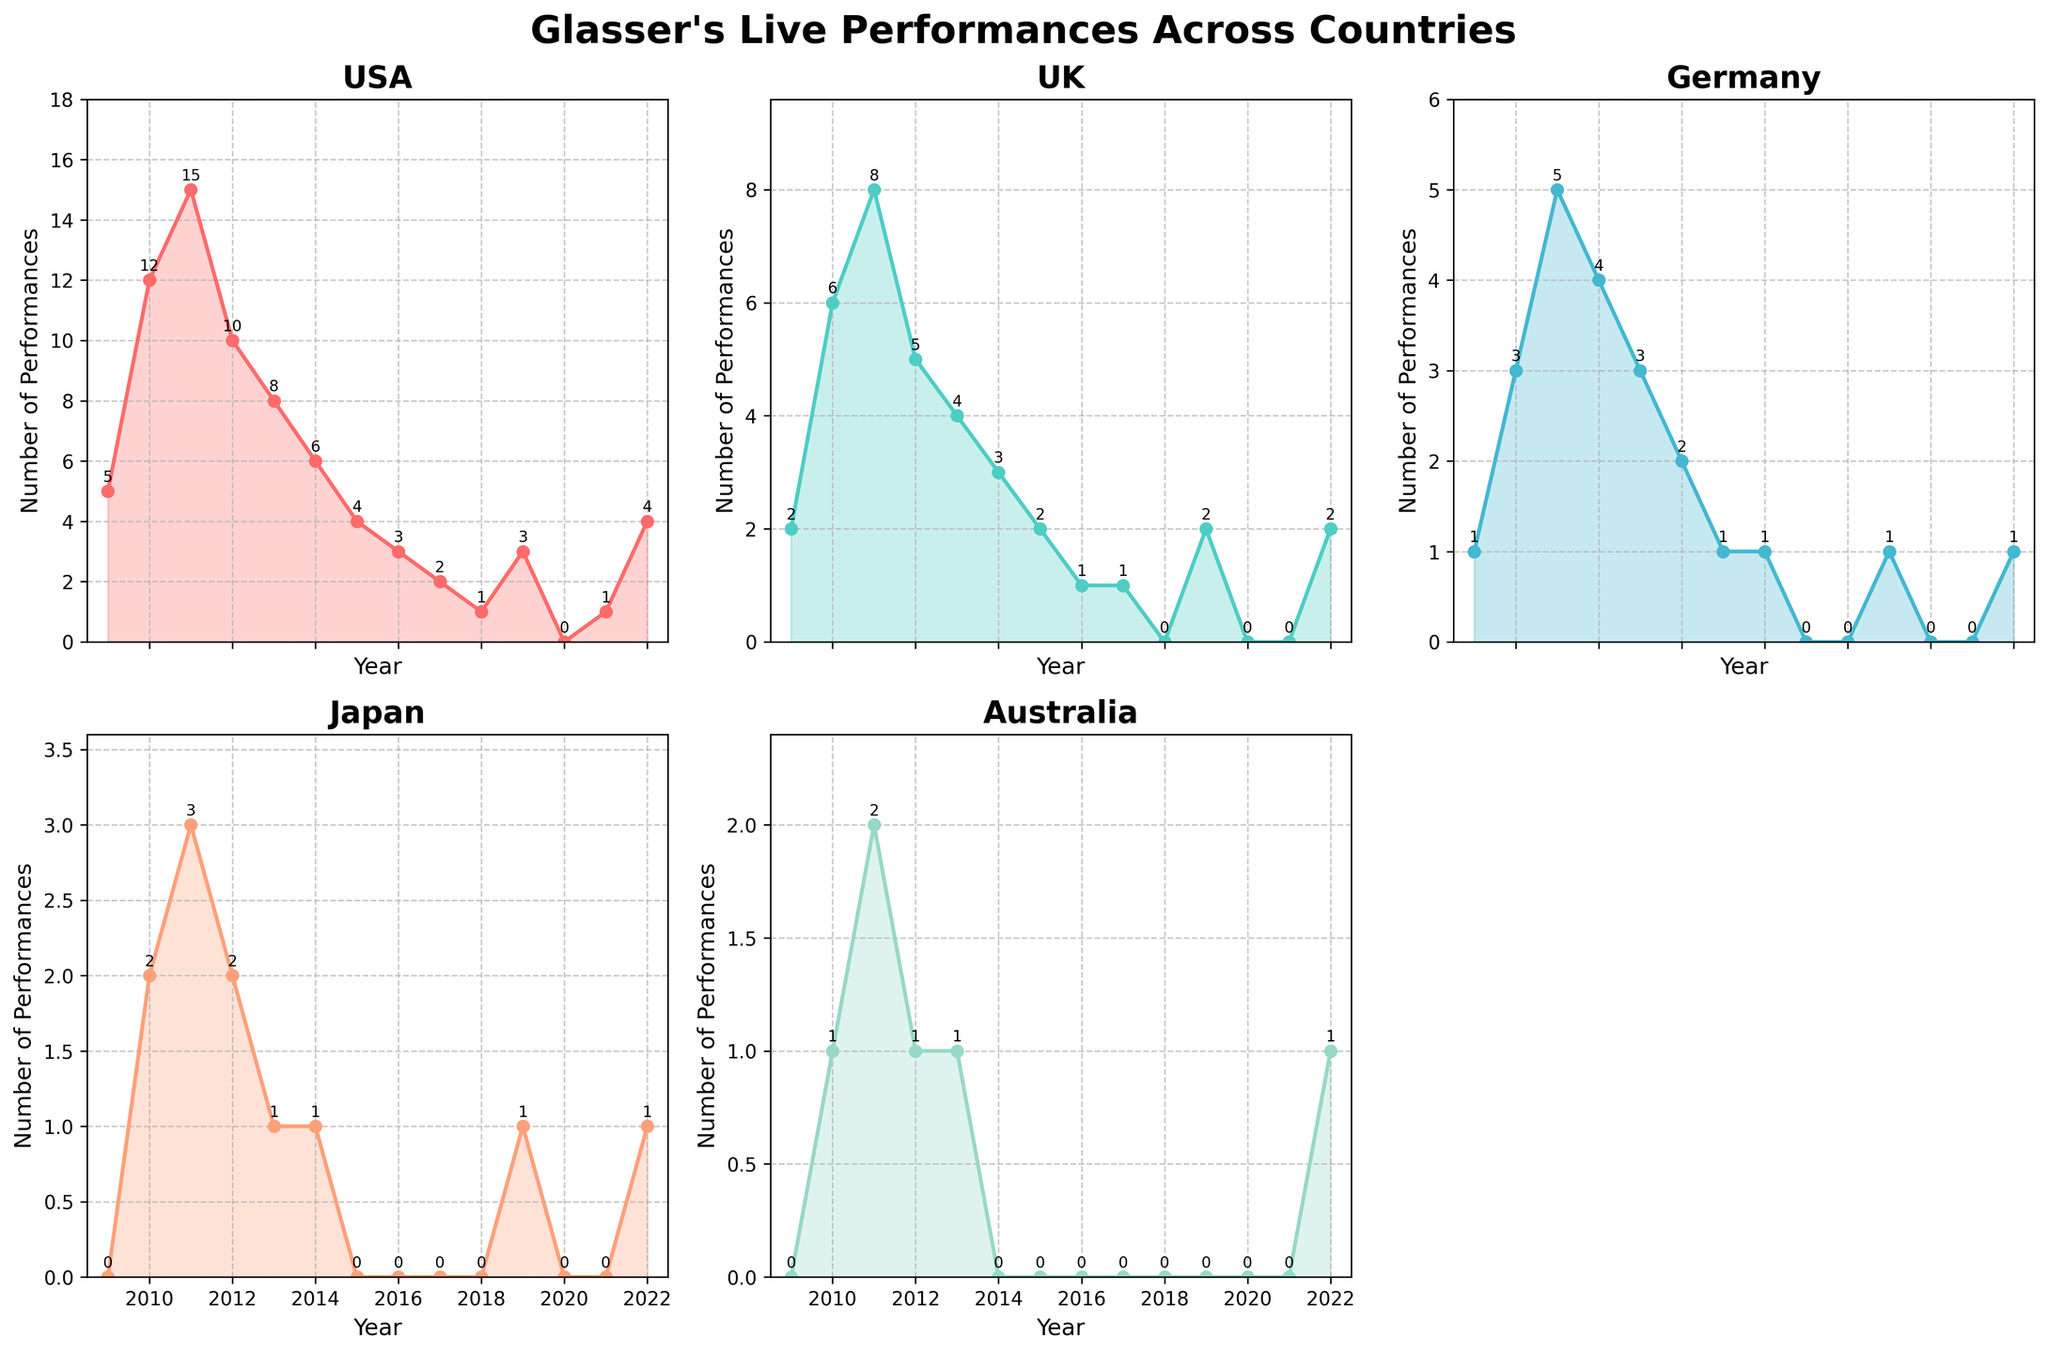What is the title of the figure? The title is displayed at the top of the figure in bold font.
Answer: Glasser's Live Performances Across Countries How many subplots are there in the figure? The plot consists of multiple smaller graphs or subplots arranged within a larger figure.
Answer: 5 Which country had the highest number of performances in any given year? Look for the peak values in each subplot and identify the highest one. The USA in 2011 has 15 performances, which is the highest.
Answer: USA In which year did Glasser perform the most shows in the UK? Examine the data points in the subplot for the UK. The highest point is found in 2011.
Answer: 2011 What was the total number of performances in Germany from 2009 to 2022? Sum up the number of performances in Germany for each year from 2009 to 2022. The total is 1+3+5+4+3+2+1+1+0+0+1+0+1 = 22.
Answer: 22 Which year shows a significant drop in live performances across all countries? Look for the year where all the subplots show a noticeable decrease in performances. This is particularly evident in 2016.
Answer: 2016 What is the trend of Glasser's performances in Japan from 2009 to 2022? Observe the overall direction or pattern of the data points in the Japan subplot. From 2009 to 2022, the trend shows a rise, then fall, with fluctuations in between and an eventual slight increase again in 2022.
Answer: Fluctuates with a rise and then a fall, ending in a slight increase In which year did Glasser have the least number of performances in the USA, excluding the years without any performances? In the USA subplot, excluding the years with zero performances, the least number is 1 in 2018.
Answer: 2018 What is the comparison between the number of performances in the UK and Australia in 2022? Examine the data points for the UK and Australia in 2022. Both countries have 2 and 1 performances respectively.
Answer: UK's 2 performances are more than Australia's 1 Which country shows the most decline in performances from their peak year to 2017? Find the peak performances for each country and compare the numbers till 2017 to see which has declined the most. The UK falls from 8 in 2011 to 1 in 2017, a decline of 7. This is the highest decline.
Answer: UK 